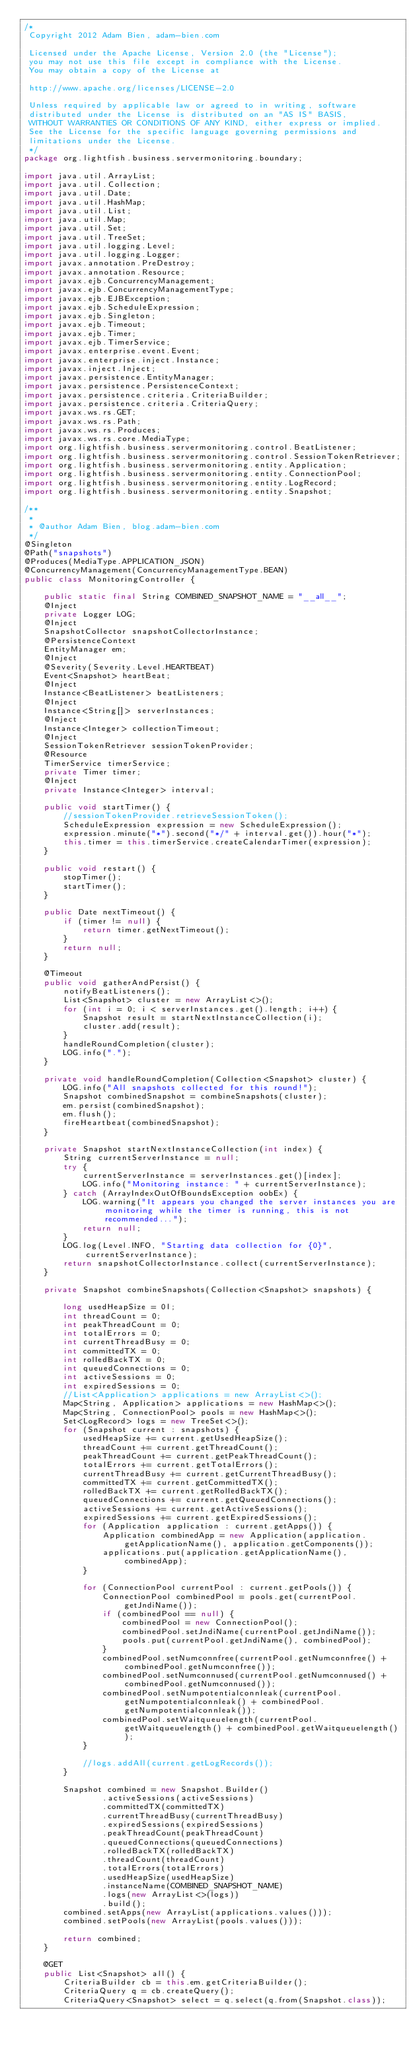<code> <loc_0><loc_0><loc_500><loc_500><_Java_>/*
 Copyright 2012 Adam Bien, adam-bien.com

 Licensed under the Apache License, Version 2.0 (the "License");
 you may not use this file except in compliance with the License.
 You may obtain a copy of the License at

 http://www.apache.org/licenses/LICENSE-2.0

 Unless required by applicable law or agreed to in writing, software
 distributed under the License is distributed on an "AS IS" BASIS,
 WITHOUT WARRANTIES OR CONDITIONS OF ANY KIND, either express or implied.
 See the License for the specific language governing permissions and
 limitations under the License.
 */
package org.lightfish.business.servermonitoring.boundary;

import java.util.ArrayList;
import java.util.Collection;
import java.util.Date;
import java.util.HashMap;
import java.util.List;
import java.util.Map;
import java.util.Set;
import java.util.TreeSet;
import java.util.logging.Level;
import java.util.logging.Logger;
import javax.annotation.PreDestroy;
import javax.annotation.Resource;
import javax.ejb.ConcurrencyManagement;
import javax.ejb.ConcurrencyManagementType;
import javax.ejb.EJBException;
import javax.ejb.ScheduleExpression;
import javax.ejb.Singleton;
import javax.ejb.Timeout;
import javax.ejb.Timer;
import javax.ejb.TimerService;
import javax.enterprise.event.Event;
import javax.enterprise.inject.Instance;
import javax.inject.Inject;
import javax.persistence.EntityManager;
import javax.persistence.PersistenceContext;
import javax.persistence.criteria.CriteriaBuilder;
import javax.persistence.criteria.CriteriaQuery;
import javax.ws.rs.GET;
import javax.ws.rs.Path;
import javax.ws.rs.Produces;
import javax.ws.rs.core.MediaType;
import org.lightfish.business.servermonitoring.control.BeatListener;
import org.lightfish.business.servermonitoring.control.SessionTokenRetriever;
import org.lightfish.business.servermonitoring.entity.Application;
import org.lightfish.business.servermonitoring.entity.ConnectionPool;
import org.lightfish.business.servermonitoring.entity.LogRecord;
import org.lightfish.business.servermonitoring.entity.Snapshot;

/**
 *
 * @author Adam Bien, blog.adam-bien.com
 */
@Singleton
@Path("snapshots")
@Produces(MediaType.APPLICATION_JSON)
@ConcurrencyManagement(ConcurrencyManagementType.BEAN)
public class MonitoringController {

    public static final String COMBINED_SNAPSHOT_NAME = "__all__";
    @Inject
    private Logger LOG;
    @Inject
    SnapshotCollector snapshotCollectorInstance;
    @PersistenceContext
    EntityManager em;
    @Inject
    @Severity(Severity.Level.HEARTBEAT)
    Event<Snapshot> heartBeat;
    @Inject
    Instance<BeatListener> beatListeners;
    @Inject
    Instance<String[]> serverInstances;
    @Inject
    Instance<Integer> collectionTimeout;
    @Inject
    SessionTokenRetriever sessionTokenProvider;
    @Resource
    TimerService timerService;
    private Timer timer;
    @Inject
    private Instance<Integer> interval;

    public void startTimer() {
        //sessionTokenProvider.retrieveSessionToken();
        ScheduleExpression expression = new ScheduleExpression();
        expression.minute("*").second("*/" + interval.get()).hour("*");
        this.timer = this.timerService.createCalendarTimer(expression);
    }

    public void restart() {
        stopTimer();
        startTimer();
    }

    public Date nextTimeout() {
        if (timer != null) {
            return timer.getNextTimeout();
        }
        return null;
    }

    @Timeout
    public void gatherAndPersist() {
        notifyBeatListeners();
        List<Snapshot> cluster = new ArrayList<>();
        for (int i = 0; i < serverInstances.get().length; i++) {
            Snapshot result = startNextInstanceCollection(i);
            cluster.add(result);
        }
        handleRoundCompletion(cluster);
        LOG.info(".");
    }

    private void handleRoundCompletion(Collection<Snapshot> cluster) {
        LOG.info("All snapshots collected for this round!");
        Snapshot combinedSnapshot = combineSnapshots(cluster);
        em.persist(combinedSnapshot);
        em.flush();
        fireHeartbeat(combinedSnapshot);
    }

    private Snapshot startNextInstanceCollection(int index) {
        String currentServerInstance = null;
        try {
            currentServerInstance = serverInstances.get()[index];
            LOG.info("Monitoring instance: " + currentServerInstance);
        } catch (ArrayIndexOutOfBoundsException oobEx) {
            LOG.warning("It appears you changed the server instances you are monitoring while the timer is running, this is not recommended...");
            return null;
        }
        LOG.log(Level.INFO, "Starting data collection for {0}", currentServerInstance);
        return snapshotCollectorInstance.collect(currentServerInstance);
    }

    private Snapshot combineSnapshots(Collection<Snapshot> snapshots) {

        long usedHeapSize = 0l;
        int threadCount = 0;
        int peakThreadCount = 0;
        int totalErrors = 0;
        int currentThreadBusy = 0;
        int committedTX = 0;
        int rolledBackTX = 0;
        int queuedConnections = 0;
        int activeSessions = 0;
        int expiredSessions = 0;
        //List<Application> applications = new ArrayList<>();
        Map<String, Application> applications = new HashMap<>();
        Map<String, ConnectionPool> pools = new HashMap<>();
        Set<LogRecord> logs = new TreeSet<>();
        for (Snapshot current : snapshots) {
            usedHeapSize += current.getUsedHeapSize();
            threadCount += current.getThreadCount();
            peakThreadCount += current.getPeakThreadCount();
            totalErrors += current.getTotalErrors();
            currentThreadBusy += current.getCurrentThreadBusy();
            committedTX += current.getCommittedTX();
            rolledBackTX += current.getRolledBackTX();
            queuedConnections += current.getQueuedConnections();
            activeSessions += current.getActiveSessions();
            expiredSessions += current.getExpiredSessions();
            for (Application application : current.getApps()) {
                Application combinedApp = new Application(application.getApplicationName(), application.getComponents());
                applications.put(application.getApplicationName(), combinedApp);
            }

            for (ConnectionPool currentPool : current.getPools()) {
                ConnectionPool combinedPool = pools.get(currentPool.getJndiName());
                if (combinedPool == null) {
                    combinedPool = new ConnectionPool();
                    combinedPool.setJndiName(currentPool.getJndiName());
                    pools.put(currentPool.getJndiName(), combinedPool);
                }
                combinedPool.setNumconnfree(currentPool.getNumconnfree() + combinedPool.getNumconnfree());
                combinedPool.setNumconnused(currentPool.getNumconnused() + combinedPool.getNumconnused());
                combinedPool.setNumpotentialconnleak(currentPool.getNumpotentialconnleak() + combinedPool.getNumpotentialconnleak());
                combinedPool.setWaitqueuelength(currentPool.getWaitqueuelength() + combinedPool.getWaitqueuelength());
            }

            //logs.addAll(current.getLogRecords());
        }

        Snapshot combined = new Snapshot.Builder()
                .activeSessions(activeSessions)
                .committedTX(committedTX)
                .currentThreadBusy(currentThreadBusy)
                .expiredSessions(expiredSessions)
                .peakThreadCount(peakThreadCount)
                .queuedConnections(queuedConnections)
                .rolledBackTX(rolledBackTX)
                .threadCount(threadCount)
                .totalErrors(totalErrors)
                .usedHeapSize(usedHeapSize)
                .instanceName(COMBINED_SNAPSHOT_NAME)
                .logs(new ArrayList<>(logs))
                .build();
        combined.setApps(new ArrayList(applications.values()));
        combined.setPools(new ArrayList(pools.values()));

        return combined;
    }

    @GET
    public List<Snapshot> all() {
        CriteriaBuilder cb = this.em.getCriteriaBuilder();
        CriteriaQuery q = cb.createQuery();
        CriteriaQuery<Snapshot> select = q.select(q.from(Snapshot.class));</code> 